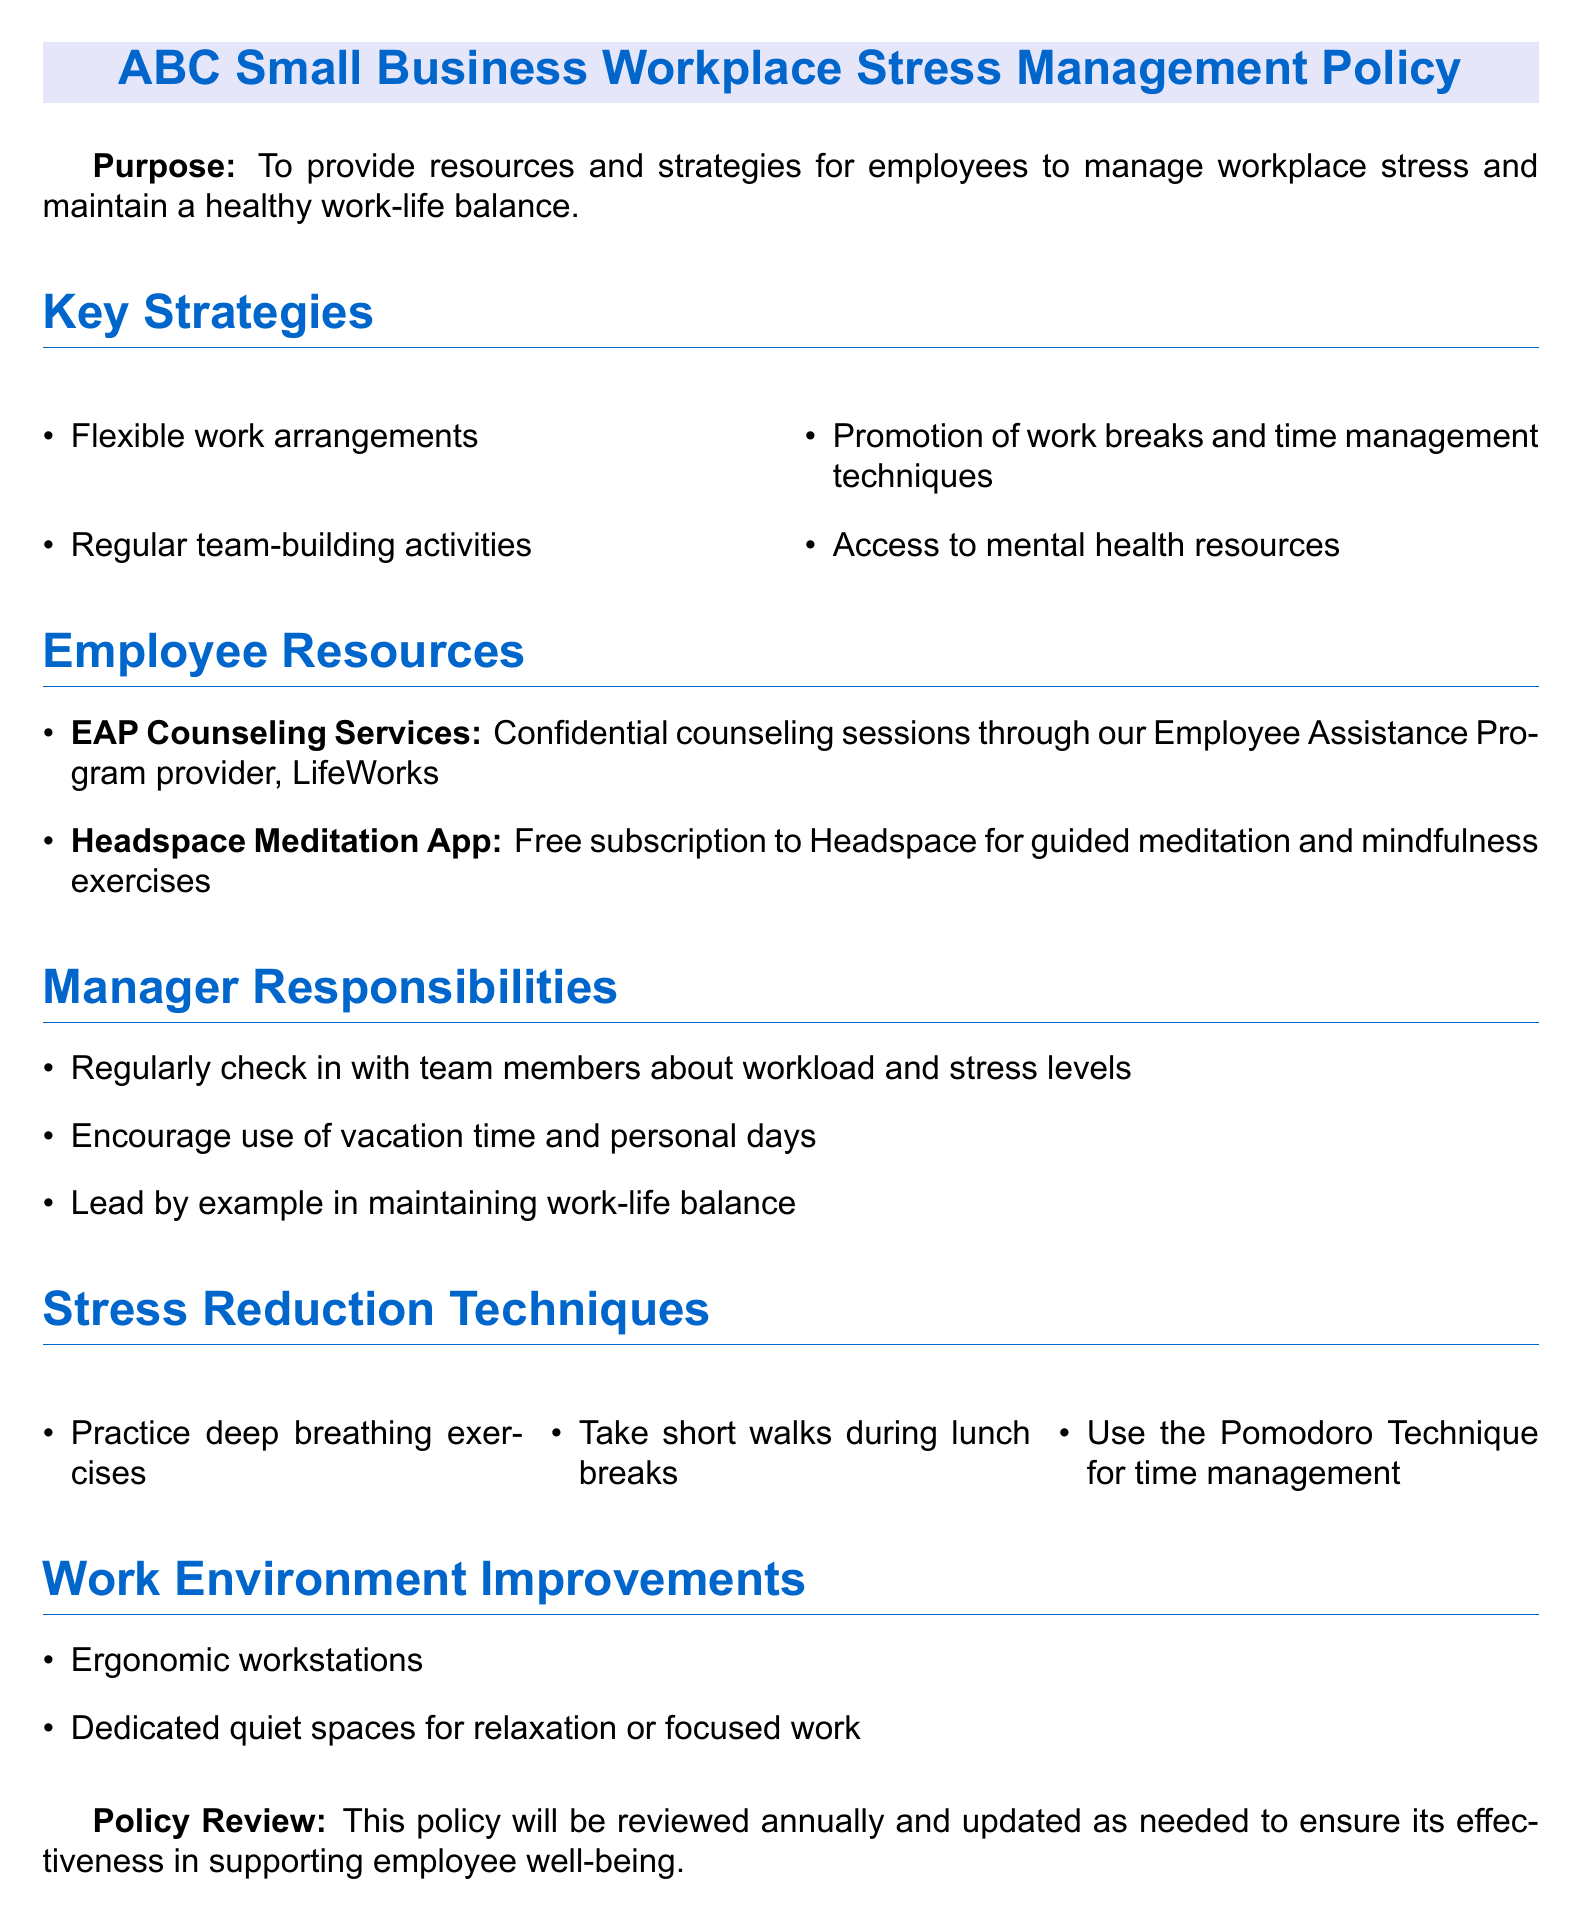What is the purpose of the policy? The purpose of the policy is to provide resources and strategies for employees to manage workplace stress and maintain a healthy work-life balance.
Answer: To provide resources and strategies for employees to manage workplace stress and maintain a healthy work-life balance What service is provided by the Employee Assistance Program? The document states that confidential counseling sessions are provided through the Employee Assistance Program.
Answer: Confidential counseling sessions What app is mentioned for meditation? The document lists the Headspace app as a resource for meditation.
Answer: Headspace Meditation App How often will the policy be reviewed? The policy states that it will be reviewed annually for effectiveness.
Answer: Annually What technique is suggested for time management? The document mentions the Pomodoro Technique as a suggested method for time management.
Answer: Pomodoro Technique What type of work arrangements are recommended? The document suggests that flexible work arrangements are a key strategy for managing stress.
Answer: Flexible work arrangements What is one responsibility of managers related to employee stress? The document states that a responsibility of managers is to regularly check in with team members about workload and stress levels.
Answer: Regularly check in with team members about workload and stress levels What are two improvements suggested for the work environment? The document mentions ergonomic workstations and dedicated quiet spaces as improvements for the work environment.
Answer: Ergonomic workstations, dedicated quiet spaces What is one stress reduction technique included in the document? The document lists taking short walks during lunch breaks as a stress reduction technique.
Answer: Take short walks during lunch breaks 